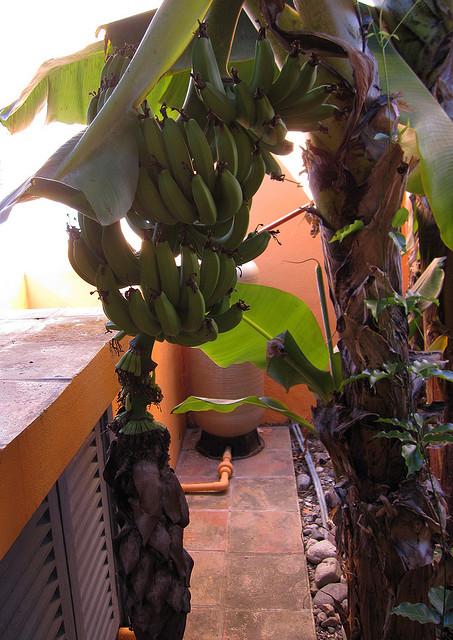Are the bananas ready to eat?
Answer briefly. No. Where are the bananas?
Answer briefly. On tree. Why are the bananas hanging upside down?
Concise answer only. Growing. 